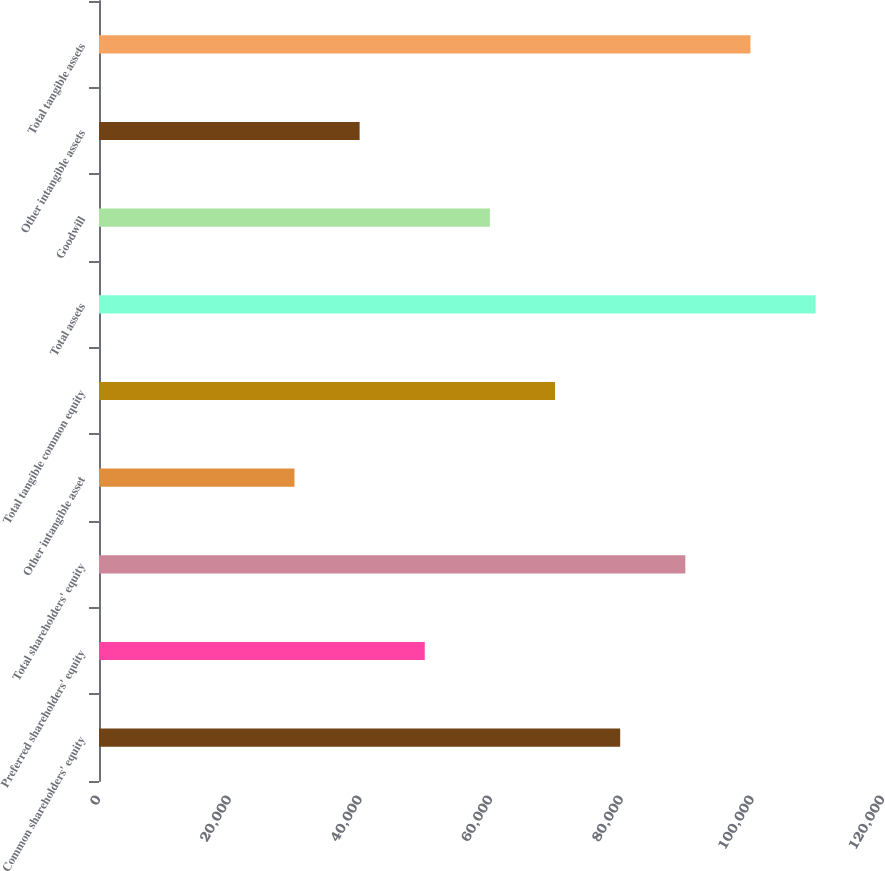Convert chart to OTSL. <chart><loc_0><loc_0><loc_500><loc_500><bar_chart><fcel>Common shareholders' equity<fcel>Preferred shareholders' equity<fcel>Total shareholders' equity<fcel>Other intangible asset<fcel>Total tangible common equity<fcel>Total assets<fcel>Goodwill<fcel>Other intangible assets<fcel>Total tangible assets<nl><fcel>79772.6<fcel>49860.6<fcel>89743.3<fcel>29919.2<fcel>69801.9<fcel>109685<fcel>59831.2<fcel>39889.9<fcel>99714<nl></chart> 